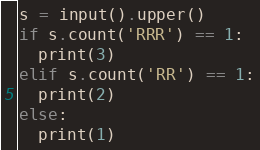Convert code to text. <code><loc_0><loc_0><loc_500><loc_500><_Python_>s = input().upper()
if s.count('RRR') == 1:
  print(3)
elif s.count('RR') == 1:
  print(2)
else:
  print(1)</code> 